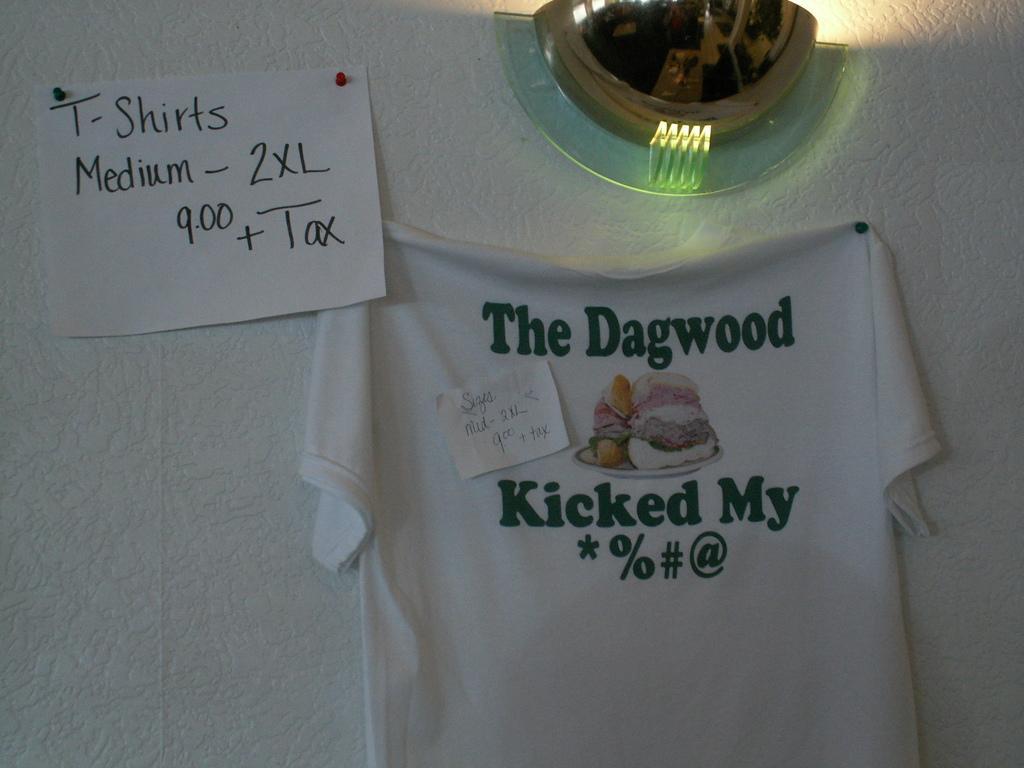In one or two sentences, can you explain what this image depicts? In this image we can see a shirt hanged to the wall with a small piece of paper pasted on it. We can also see a paper and a ceiling light on the wall. 